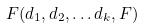Convert formula to latex. <formula><loc_0><loc_0><loc_500><loc_500>F ( d _ { 1 } , d _ { 2 } , \dots d _ { k } , F )</formula> 